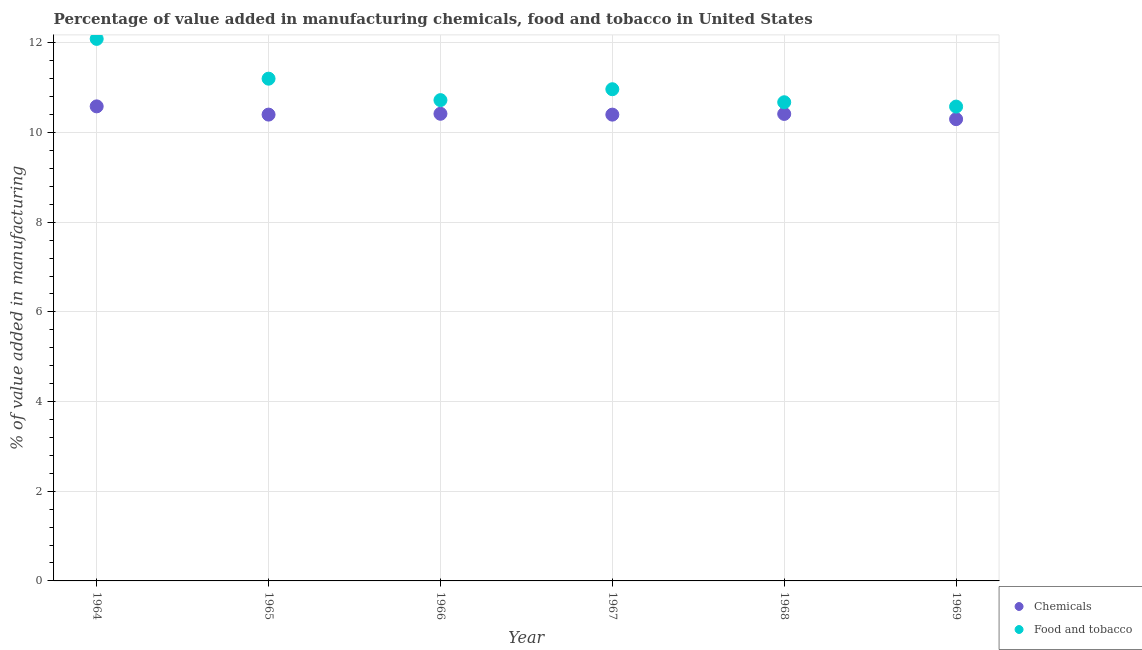How many different coloured dotlines are there?
Ensure brevity in your answer.  2. What is the value added by manufacturing food and tobacco in 1964?
Provide a succinct answer. 12.09. Across all years, what is the maximum value added by manufacturing food and tobacco?
Your answer should be compact. 12.09. Across all years, what is the minimum value added by manufacturing food and tobacco?
Offer a terse response. 10.58. In which year was the value added by manufacturing food and tobacco maximum?
Provide a succinct answer. 1964. In which year was the value added by manufacturing food and tobacco minimum?
Offer a terse response. 1969. What is the total value added by manufacturing food and tobacco in the graph?
Your answer should be very brief. 66.23. What is the difference between the value added by manufacturing food and tobacco in 1966 and that in 1969?
Ensure brevity in your answer.  0.14. What is the difference between the value added by manufacturing food and tobacco in 1966 and the value added by  manufacturing chemicals in 1967?
Offer a terse response. 0.32. What is the average value added by manufacturing food and tobacco per year?
Your response must be concise. 11.04. In the year 1966, what is the difference between the value added by manufacturing food and tobacco and value added by  manufacturing chemicals?
Ensure brevity in your answer.  0.3. In how many years, is the value added by  manufacturing chemicals greater than 2 %?
Your answer should be very brief. 6. What is the ratio of the value added by manufacturing food and tobacco in 1967 to that in 1969?
Keep it short and to the point. 1.04. What is the difference between the highest and the second highest value added by  manufacturing chemicals?
Your response must be concise. 0.17. What is the difference between the highest and the lowest value added by manufacturing food and tobacco?
Provide a succinct answer. 1.51. In how many years, is the value added by manufacturing food and tobacco greater than the average value added by manufacturing food and tobacco taken over all years?
Give a very brief answer. 2. How many years are there in the graph?
Give a very brief answer. 6. Are the values on the major ticks of Y-axis written in scientific E-notation?
Offer a terse response. No. Where does the legend appear in the graph?
Offer a terse response. Bottom right. What is the title of the graph?
Give a very brief answer. Percentage of value added in manufacturing chemicals, food and tobacco in United States. What is the label or title of the X-axis?
Your answer should be compact. Year. What is the label or title of the Y-axis?
Offer a very short reply. % of value added in manufacturing. What is the % of value added in manufacturing in Chemicals in 1964?
Give a very brief answer. 10.58. What is the % of value added in manufacturing in Food and tobacco in 1964?
Provide a short and direct response. 12.09. What is the % of value added in manufacturing of Chemicals in 1965?
Ensure brevity in your answer.  10.4. What is the % of value added in manufacturing in Food and tobacco in 1965?
Provide a short and direct response. 11.2. What is the % of value added in manufacturing of Chemicals in 1966?
Offer a very short reply. 10.42. What is the % of value added in manufacturing in Food and tobacco in 1966?
Ensure brevity in your answer.  10.72. What is the % of value added in manufacturing of Chemicals in 1967?
Your answer should be very brief. 10.4. What is the % of value added in manufacturing in Food and tobacco in 1967?
Keep it short and to the point. 10.97. What is the % of value added in manufacturing in Chemicals in 1968?
Your answer should be very brief. 10.41. What is the % of value added in manufacturing of Food and tobacco in 1968?
Provide a succinct answer. 10.67. What is the % of value added in manufacturing in Chemicals in 1969?
Your response must be concise. 10.3. What is the % of value added in manufacturing in Food and tobacco in 1969?
Your response must be concise. 10.58. Across all years, what is the maximum % of value added in manufacturing of Chemicals?
Ensure brevity in your answer.  10.58. Across all years, what is the maximum % of value added in manufacturing in Food and tobacco?
Provide a succinct answer. 12.09. Across all years, what is the minimum % of value added in manufacturing of Chemicals?
Offer a terse response. 10.3. Across all years, what is the minimum % of value added in manufacturing of Food and tobacco?
Ensure brevity in your answer.  10.58. What is the total % of value added in manufacturing of Chemicals in the graph?
Keep it short and to the point. 62.51. What is the total % of value added in manufacturing of Food and tobacco in the graph?
Make the answer very short. 66.23. What is the difference between the % of value added in manufacturing of Chemicals in 1964 and that in 1965?
Give a very brief answer. 0.18. What is the difference between the % of value added in manufacturing in Food and tobacco in 1964 and that in 1965?
Your response must be concise. 0.89. What is the difference between the % of value added in manufacturing of Chemicals in 1964 and that in 1966?
Your response must be concise. 0.17. What is the difference between the % of value added in manufacturing of Food and tobacco in 1964 and that in 1966?
Your response must be concise. 1.37. What is the difference between the % of value added in manufacturing of Chemicals in 1964 and that in 1967?
Give a very brief answer. 0.18. What is the difference between the % of value added in manufacturing of Food and tobacco in 1964 and that in 1967?
Ensure brevity in your answer.  1.12. What is the difference between the % of value added in manufacturing in Chemicals in 1964 and that in 1968?
Give a very brief answer. 0.17. What is the difference between the % of value added in manufacturing in Food and tobacco in 1964 and that in 1968?
Your answer should be very brief. 1.41. What is the difference between the % of value added in manufacturing of Chemicals in 1964 and that in 1969?
Offer a terse response. 0.29. What is the difference between the % of value added in manufacturing in Food and tobacco in 1964 and that in 1969?
Your response must be concise. 1.51. What is the difference between the % of value added in manufacturing in Chemicals in 1965 and that in 1966?
Your answer should be very brief. -0.02. What is the difference between the % of value added in manufacturing in Food and tobacco in 1965 and that in 1966?
Offer a terse response. 0.48. What is the difference between the % of value added in manufacturing of Chemicals in 1965 and that in 1967?
Provide a short and direct response. 0. What is the difference between the % of value added in manufacturing in Food and tobacco in 1965 and that in 1967?
Ensure brevity in your answer.  0.24. What is the difference between the % of value added in manufacturing of Chemicals in 1965 and that in 1968?
Your response must be concise. -0.02. What is the difference between the % of value added in manufacturing of Food and tobacco in 1965 and that in 1968?
Offer a terse response. 0.53. What is the difference between the % of value added in manufacturing of Chemicals in 1965 and that in 1969?
Your response must be concise. 0.1. What is the difference between the % of value added in manufacturing in Food and tobacco in 1965 and that in 1969?
Your response must be concise. 0.62. What is the difference between the % of value added in manufacturing of Chemicals in 1966 and that in 1967?
Your answer should be compact. 0.02. What is the difference between the % of value added in manufacturing in Food and tobacco in 1966 and that in 1967?
Give a very brief answer. -0.24. What is the difference between the % of value added in manufacturing of Chemicals in 1966 and that in 1968?
Provide a short and direct response. 0. What is the difference between the % of value added in manufacturing of Food and tobacco in 1966 and that in 1968?
Keep it short and to the point. 0.05. What is the difference between the % of value added in manufacturing in Chemicals in 1966 and that in 1969?
Provide a succinct answer. 0.12. What is the difference between the % of value added in manufacturing in Food and tobacco in 1966 and that in 1969?
Keep it short and to the point. 0.14. What is the difference between the % of value added in manufacturing of Chemicals in 1967 and that in 1968?
Your response must be concise. -0.02. What is the difference between the % of value added in manufacturing in Food and tobacco in 1967 and that in 1968?
Ensure brevity in your answer.  0.29. What is the difference between the % of value added in manufacturing in Chemicals in 1967 and that in 1969?
Keep it short and to the point. 0.1. What is the difference between the % of value added in manufacturing in Food and tobacco in 1967 and that in 1969?
Give a very brief answer. 0.39. What is the difference between the % of value added in manufacturing in Chemicals in 1968 and that in 1969?
Your answer should be compact. 0.12. What is the difference between the % of value added in manufacturing in Food and tobacco in 1968 and that in 1969?
Give a very brief answer. 0.1. What is the difference between the % of value added in manufacturing of Chemicals in 1964 and the % of value added in manufacturing of Food and tobacco in 1965?
Your response must be concise. -0.62. What is the difference between the % of value added in manufacturing of Chemicals in 1964 and the % of value added in manufacturing of Food and tobacco in 1966?
Provide a short and direct response. -0.14. What is the difference between the % of value added in manufacturing in Chemicals in 1964 and the % of value added in manufacturing in Food and tobacco in 1967?
Offer a very short reply. -0.38. What is the difference between the % of value added in manufacturing in Chemicals in 1964 and the % of value added in manufacturing in Food and tobacco in 1968?
Ensure brevity in your answer.  -0.09. What is the difference between the % of value added in manufacturing in Chemicals in 1964 and the % of value added in manufacturing in Food and tobacco in 1969?
Your response must be concise. 0.01. What is the difference between the % of value added in manufacturing of Chemicals in 1965 and the % of value added in manufacturing of Food and tobacco in 1966?
Ensure brevity in your answer.  -0.32. What is the difference between the % of value added in manufacturing of Chemicals in 1965 and the % of value added in manufacturing of Food and tobacco in 1967?
Provide a succinct answer. -0.57. What is the difference between the % of value added in manufacturing of Chemicals in 1965 and the % of value added in manufacturing of Food and tobacco in 1968?
Your answer should be very brief. -0.28. What is the difference between the % of value added in manufacturing of Chemicals in 1965 and the % of value added in manufacturing of Food and tobacco in 1969?
Your response must be concise. -0.18. What is the difference between the % of value added in manufacturing in Chemicals in 1966 and the % of value added in manufacturing in Food and tobacco in 1967?
Your response must be concise. -0.55. What is the difference between the % of value added in manufacturing in Chemicals in 1966 and the % of value added in manufacturing in Food and tobacco in 1968?
Your answer should be compact. -0.26. What is the difference between the % of value added in manufacturing in Chemicals in 1966 and the % of value added in manufacturing in Food and tobacco in 1969?
Provide a short and direct response. -0.16. What is the difference between the % of value added in manufacturing of Chemicals in 1967 and the % of value added in manufacturing of Food and tobacco in 1968?
Offer a terse response. -0.28. What is the difference between the % of value added in manufacturing of Chemicals in 1967 and the % of value added in manufacturing of Food and tobacco in 1969?
Make the answer very short. -0.18. What is the difference between the % of value added in manufacturing in Chemicals in 1968 and the % of value added in manufacturing in Food and tobacco in 1969?
Provide a succinct answer. -0.16. What is the average % of value added in manufacturing of Chemicals per year?
Offer a terse response. 10.42. What is the average % of value added in manufacturing in Food and tobacco per year?
Ensure brevity in your answer.  11.04. In the year 1964, what is the difference between the % of value added in manufacturing in Chemicals and % of value added in manufacturing in Food and tobacco?
Make the answer very short. -1.5. In the year 1965, what is the difference between the % of value added in manufacturing of Chemicals and % of value added in manufacturing of Food and tobacco?
Your answer should be very brief. -0.8. In the year 1966, what is the difference between the % of value added in manufacturing of Chemicals and % of value added in manufacturing of Food and tobacco?
Offer a terse response. -0.3. In the year 1967, what is the difference between the % of value added in manufacturing of Chemicals and % of value added in manufacturing of Food and tobacco?
Give a very brief answer. -0.57. In the year 1968, what is the difference between the % of value added in manufacturing of Chemicals and % of value added in manufacturing of Food and tobacco?
Your response must be concise. -0.26. In the year 1969, what is the difference between the % of value added in manufacturing of Chemicals and % of value added in manufacturing of Food and tobacco?
Your response must be concise. -0.28. What is the ratio of the % of value added in manufacturing of Chemicals in 1964 to that in 1965?
Provide a short and direct response. 1.02. What is the ratio of the % of value added in manufacturing in Food and tobacco in 1964 to that in 1965?
Provide a succinct answer. 1.08. What is the ratio of the % of value added in manufacturing of Chemicals in 1964 to that in 1966?
Ensure brevity in your answer.  1.02. What is the ratio of the % of value added in manufacturing in Food and tobacco in 1964 to that in 1966?
Offer a terse response. 1.13. What is the ratio of the % of value added in manufacturing in Chemicals in 1964 to that in 1967?
Make the answer very short. 1.02. What is the ratio of the % of value added in manufacturing of Food and tobacco in 1964 to that in 1967?
Provide a short and direct response. 1.1. What is the ratio of the % of value added in manufacturing in Chemicals in 1964 to that in 1968?
Offer a terse response. 1.02. What is the ratio of the % of value added in manufacturing in Food and tobacco in 1964 to that in 1968?
Your answer should be compact. 1.13. What is the ratio of the % of value added in manufacturing of Chemicals in 1964 to that in 1969?
Provide a succinct answer. 1.03. What is the ratio of the % of value added in manufacturing in Food and tobacco in 1964 to that in 1969?
Ensure brevity in your answer.  1.14. What is the ratio of the % of value added in manufacturing in Food and tobacco in 1965 to that in 1966?
Ensure brevity in your answer.  1.04. What is the ratio of the % of value added in manufacturing of Chemicals in 1965 to that in 1967?
Ensure brevity in your answer.  1. What is the ratio of the % of value added in manufacturing of Food and tobacco in 1965 to that in 1967?
Provide a succinct answer. 1.02. What is the ratio of the % of value added in manufacturing in Food and tobacco in 1965 to that in 1968?
Your answer should be compact. 1.05. What is the ratio of the % of value added in manufacturing in Chemicals in 1965 to that in 1969?
Offer a very short reply. 1.01. What is the ratio of the % of value added in manufacturing of Food and tobacco in 1965 to that in 1969?
Provide a succinct answer. 1.06. What is the ratio of the % of value added in manufacturing in Chemicals in 1966 to that in 1967?
Give a very brief answer. 1. What is the ratio of the % of value added in manufacturing in Food and tobacco in 1966 to that in 1967?
Offer a terse response. 0.98. What is the ratio of the % of value added in manufacturing of Chemicals in 1966 to that in 1968?
Keep it short and to the point. 1. What is the ratio of the % of value added in manufacturing of Food and tobacco in 1966 to that in 1968?
Offer a very short reply. 1. What is the ratio of the % of value added in manufacturing of Chemicals in 1966 to that in 1969?
Provide a short and direct response. 1.01. What is the ratio of the % of value added in manufacturing of Food and tobacco in 1966 to that in 1969?
Give a very brief answer. 1.01. What is the ratio of the % of value added in manufacturing of Food and tobacco in 1967 to that in 1968?
Ensure brevity in your answer.  1.03. What is the ratio of the % of value added in manufacturing in Chemicals in 1967 to that in 1969?
Make the answer very short. 1.01. What is the ratio of the % of value added in manufacturing of Food and tobacco in 1967 to that in 1969?
Your response must be concise. 1.04. What is the ratio of the % of value added in manufacturing of Chemicals in 1968 to that in 1969?
Offer a very short reply. 1.01. What is the ratio of the % of value added in manufacturing in Food and tobacco in 1968 to that in 1969?
Provide a succinct answer. 1.01. What is the difference between the highest and the second highest % of value added in manufacturing in Chemicals?
Offer a very short reply. 0.17. What is the difference between the highest and the second highest % of value added in manufacturing of Food and tobacco?
Offer a very short reply. 0.89. What is the difference between the highest and the lowest % of value added in manufacturing of Chemicals?
Your answer should be compact. 0.29. What is the difference between the highest and the lowest % of value added in manufacturing in Food and tobacco?
Provide a succinct answer. 1.51. 